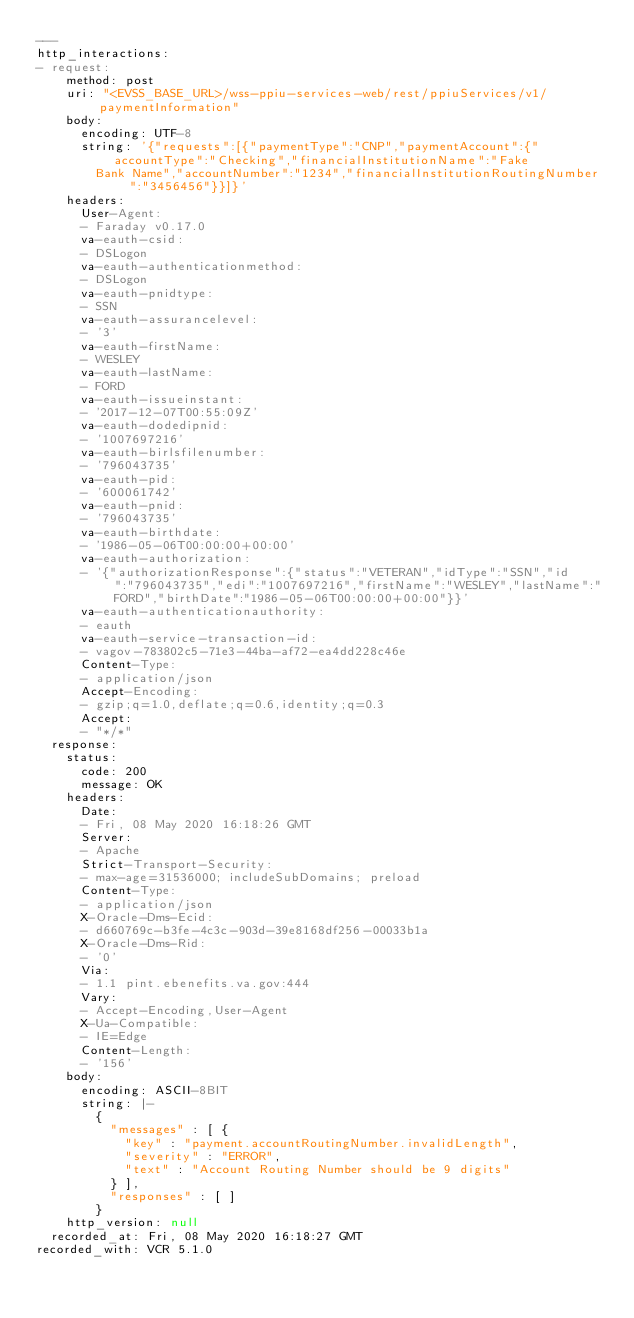<code> <loc_0><loc_0><loc_500><loc_500><_YAML_>---
http_interactions:
- request:
    method: post
    uri: "<EVSS_BASE_URL>/wss-ppiu-services-web/rest/ppiuServices/v1/paymentInformation"
    body:
      encoding: UTF-8
      string: '{"requests":[{"paymentType":"CNP","paymentAccount":{"accountType":"Checking","financialInstitutionName":"Fake
        Bank Name","accountNumber":"1234","financialInstitutionRoutingNumber":"3456456"}}]}'
    headers:
      User-Agent:
      - Faraday v0.17.0
      va-eauth-csid:
      - DSLogon
      va-eauth-authenticationmethod:
      - DSLogon
      va-eauth-pnidtype:
      - SSN
      va-eauth-assurancelevel:
      - '3'
      va-eauth-firstName:
      - WESLEY
      va-eauth-lastName:
      - FORD
      va-eauth-issueinstant:
      - '2017-12-07T00:55:09Z'
      va-eauth-dodedipnid:
      - '1007697216'
      va-eauth-birlsfilenumber:
      - '796043735'
      va-eauth-pid:
      - '600061742'
      va-eauth-pnid:
      - '796043735'
      va-eauth-birthdate:
      - '1986-05-06T00:00:00+00:00'
      va-eauth-authorization:
      - '{"authorizationResponse":{"status":"VETERAN","idType":"SSN","id":"796043735","edi":"1007697216","firstName":"WESLEY","lastName":"FORD","birthDate":"1986-05-06T00:00:00+00:00"}}'
      va-eauth-authenticationauthority:
      - eauth
      va-eauth-service-transaction-id:
      - vagov-783802c5-71e3-44ba-af72-ea4dd228c46e
      Content-Type:
      - application/json
      Accept-Encoding:
      - gzip;q=1.0,deflate;q=0.6,identity;q=0.3
      Accept:
      - "*/*"
  response:
    status:
      code: 200
      message: OK
    headers:
      Date:
      - Fri, 08 May 2020 16:18:26 GMT
      Server:
      - Apache
      Strict-Transport-Security:
      - max-age=31536000; includeSubDomains; preload
      Content-Type:
      - application/json
      X-Oracle-Dms-Ecid:
      - d660769c-b3fe-4c3c-903d-39e8168df256-00033b1a
      X-Oracle-Dms-Rid:
      - '0'
      Via:
      - 1.1 pint.ebenefits.va.gov:444
      Vary:
      - Accept-Encoding,User-Agent
      X-Ua-Compatible:
      - IE=Edge
      Content-Length:
      - '156'
    body:
      encoding: ASCII-8BIT
      string: |-
        {
          "messages" : [ {
            "key" : "payment.accountRoutingNumber.invalidLength",
            "severity" : "ERROR",
            "text" : "Account Routing Number should be 9 digits"
          } ],
          "responses" : [ ]
        }
    http_version: null
  recorded_at: Fri, 08 May 2020 16:18:27 GMT
recorded_with: VCR 5.1.0
</code> 